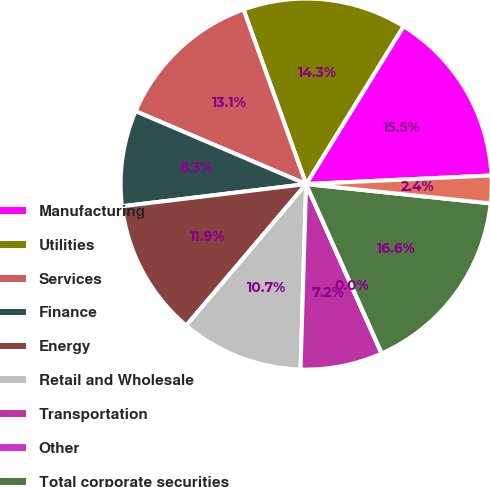<chart> <loc_0><loc_0><loc_500><loc_500><pie_chart><fcel>Manufacturing<fcel>Utilities<fcel>Services<fcel>Finance<fcel>Energy<fcel>Retail and Wholesale<fcel>Transportation<fcel>Other<fcel>Total corporate securities<fcel>Asset-backed securities(2)<nl><fcel>15.46%<fcel>14.28%<fcel>13.09%<fcel>8.34%<fcel>11.9%<fcel>10.71%<fcel>7.15%<fcel>0.02%<fcel>16.65%<fcel>2.4%<nl></chart> 